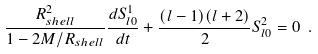Convert formula to latex. <formula><loc_0><loc_0><loc_500><loc_500>\frac { R _ { s h e l l } ^ { 2 } } { 1 - 2 M / R _ { s h e l l } } \frac { d S ^ { 1 } _ { l 0 } } { d t } + \frac { ( l - 1 ) ( l + 2 ) } { 2 } S ^ { 2 } _ { l 0 } = 0 \ .</formula> 